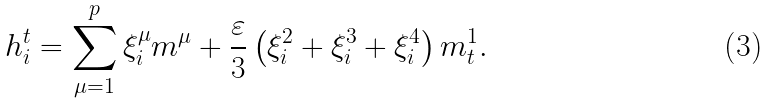<formula> <loc_0><loc_0><loc_500><loc_500>h _ { i } ^ { t } = \sum _ { \mu = 1 } ^ { p } \xi ^ { \mu } _ { i } m ^ { \mu } + \frac { \varepsilon } { 3 } \left ( \xi ^ { 2 } _ { i } + \xi ^ { 3 } _ { i } + \xi ^ { 4 } _ { i } \right ) m _ { t } ^ { 1 } .</formula> 